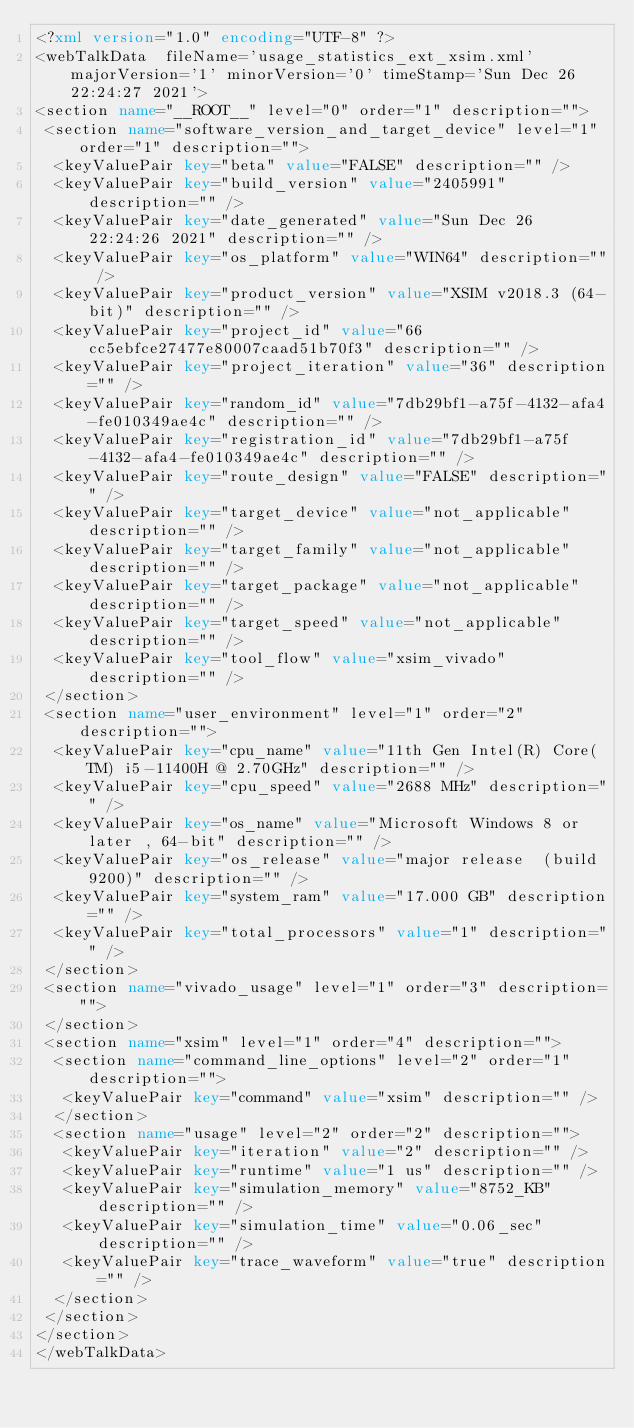<code> <loc_0><loc_0><loc_500><loc_500><_XML_><?xml version="1.0" encoding="UTF-8" ?>
<webTalkData  fileName='usage_statistics_ext_xsim.xml'  majorVersion='1' minorVersion='0' timeStamp='Sun Dec 26 22:24:27 2021'>
<section name="__ROOT__" level="0" order="1" description="">
 <section name="software_version_and_target_device" level="1" order="1" description="">
  <keyValuePair key="beta" value="FALSE" description="" />
  <keyValuePair key="build_version" value="2405991" description="" />
  <keyValuePair key="date_generated" value="Sun Dec 26 22:24:26 2021" description="" />
  <keyValuePair key="os_platform" value="WIN64" description="" />
  <keyValuePair key="product_version" value="XSIM v2018.3 (64-bit)" description="" />
  <keyValuePair key="project_id" value="66cc5ebfce27477e80007caad51b70f3" description="" />
  <keyValuePair key="project_iteration" value="36" description="" />
  <keyValuePair key="random_id" value="7db29bf1-a75f-4132-afa4-fe010349ae4c" description="" />
  <keyValuePair key="registration_id" value="7db29bf1-a75f-4132-afa4-fe010349ae4c" description="" />
  <keyValuePair key="route_design" value="FALSE" description="" />
  <keyValuePair key="target_device" value="not_applicable" description="" />
  <keyValuePair key="target_family" value="not_applicable" description="" />
  <keyValuePair key="target_package" value="not_applicable" description="" />
  <keyValuePair key="target_speed" value="not_applicable" description="" />
  <keyValuePair key="tool_flow" value="xsim_vivado" description="" />
 </section>
 <section name="user_environment" level="1" order="2" description="">
  <keyValuePair key="cpu_name" value="11th Gen Intel(R) Core(TM) i5-11400H @ 2.70GHz" description="" />
  <keyValuePair key="cpu_speed" value="2688 MHz" description="" />
  <keyValuePair key="os_name" value="Microsoft Windows 8 or later , 64-bit" description="" />
  <keyValuePair key="os_release" value="major release  (build 9200)" description="" />
  <keyValuePair key="system_ram" value="17.000 GB" description="" />
  <keyValuePair key="total_processors" value="1" description="" />
 </section>
 <section name="vivado_usage" level="1" order="3" description="">
 </section>
 <section name="xsim" level="1" order="4" description="">
  <section name="command_line_options" level="2" order="1" description="">
   <keyValuePair key="command" value="xsim" description="" />
  </section>
  <section name="usage" level="2" order="2" description="">
   <keyValuePair key="iteration" value="2" description="" />
   <keyValuePair key="runtime" value="1 us" description="" />
   <keyValuePair key="simulation_memory" value="8752_KB" description="" />
   <keyValuePair key="simulation_time" value="0.06_sec" description="" />
   <keyValuePair key="trace_waveform" value="true" description="" />
  </section>
 </section>
</section>
</webTalkData>
</code> 